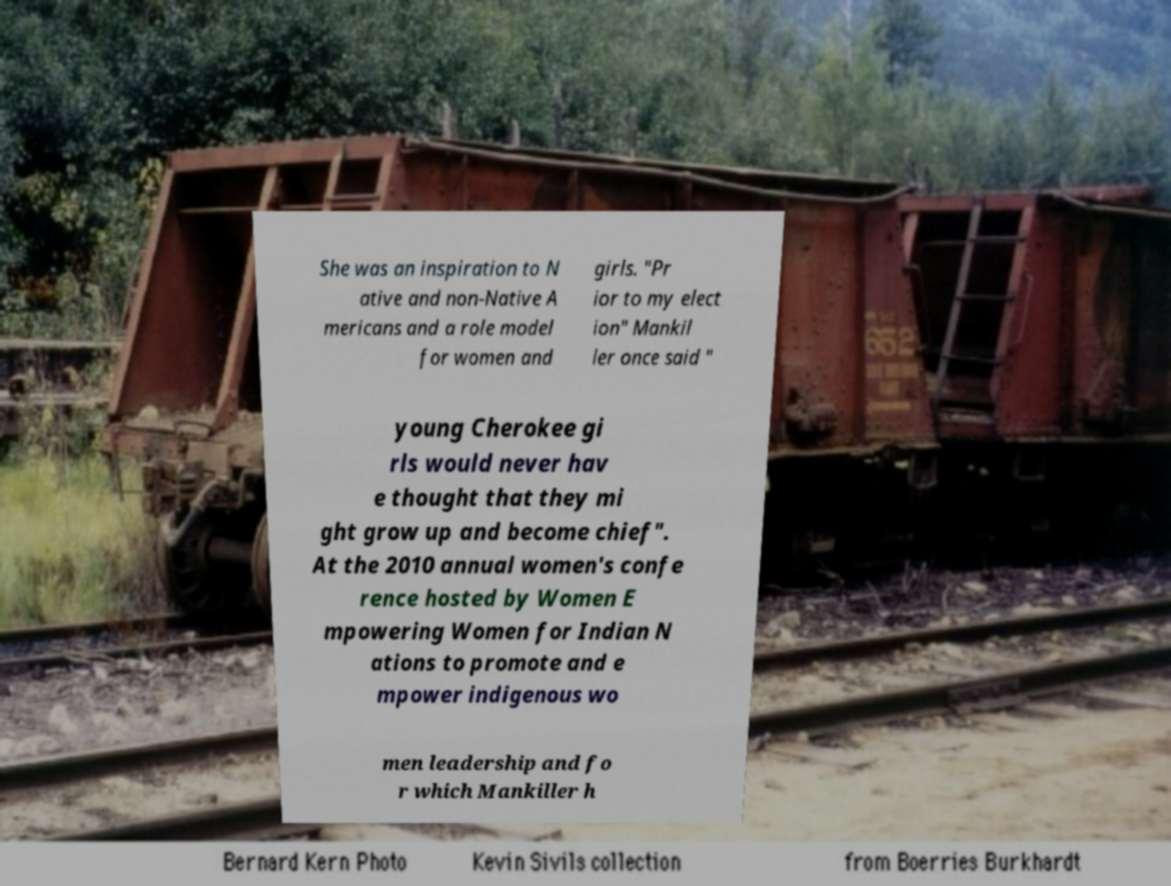For documentation purposes, I need the text within this image transcribed. Could you provide that? She was an inspiration to N ative and non-Native A mericans and a role model for women and girls. "Pr ior to my elect ion" Mankil ler once said " young Cherokee gi rls would never hav e thought that they mi ght grow up and become chief". At the 2010 annual women's confe rence hosted by Women E mpowering Women for Indian N ations to promote and e mpower indigenous wo men leadership and fo r which Mankiller h 